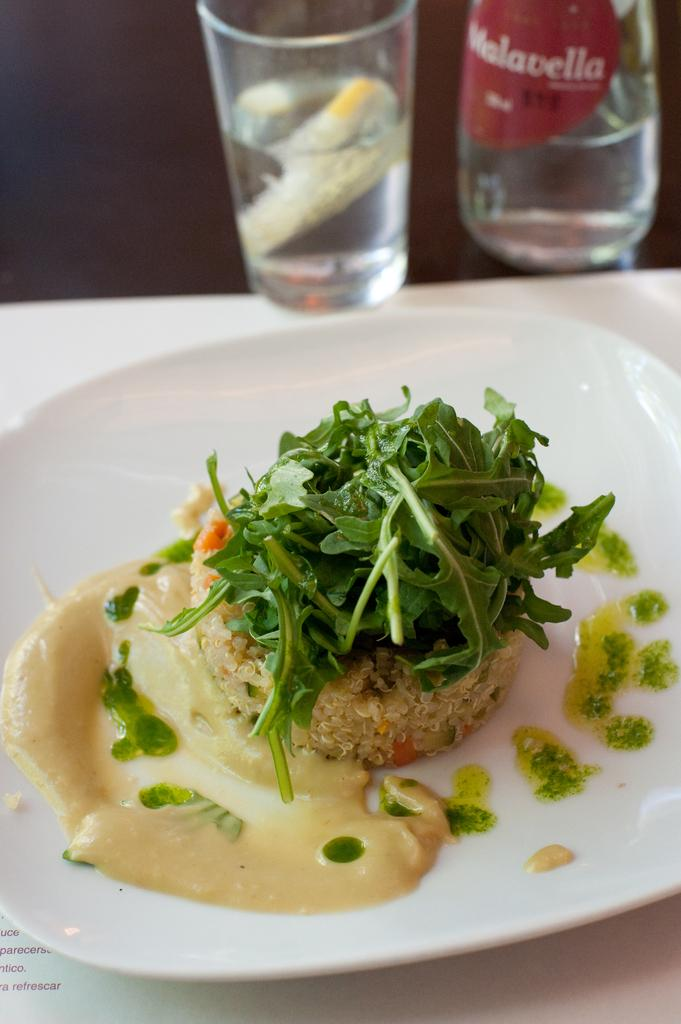<image>
Relay a brief, clear account of the picture shown. A table has a plate of rice and lettuces and a cup of Melavella. 